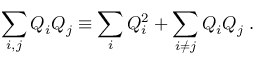<formula> <loc_0><loc_0><loc_500><loc_500>\sum _ { i , j } Q _ { i } Q _ { j } \equiv \sum _ { i } Q _ { i } ^ { 2 } + \sum _ { i \neq j } Q _ { i } Q _ { j } \, .</formula> 